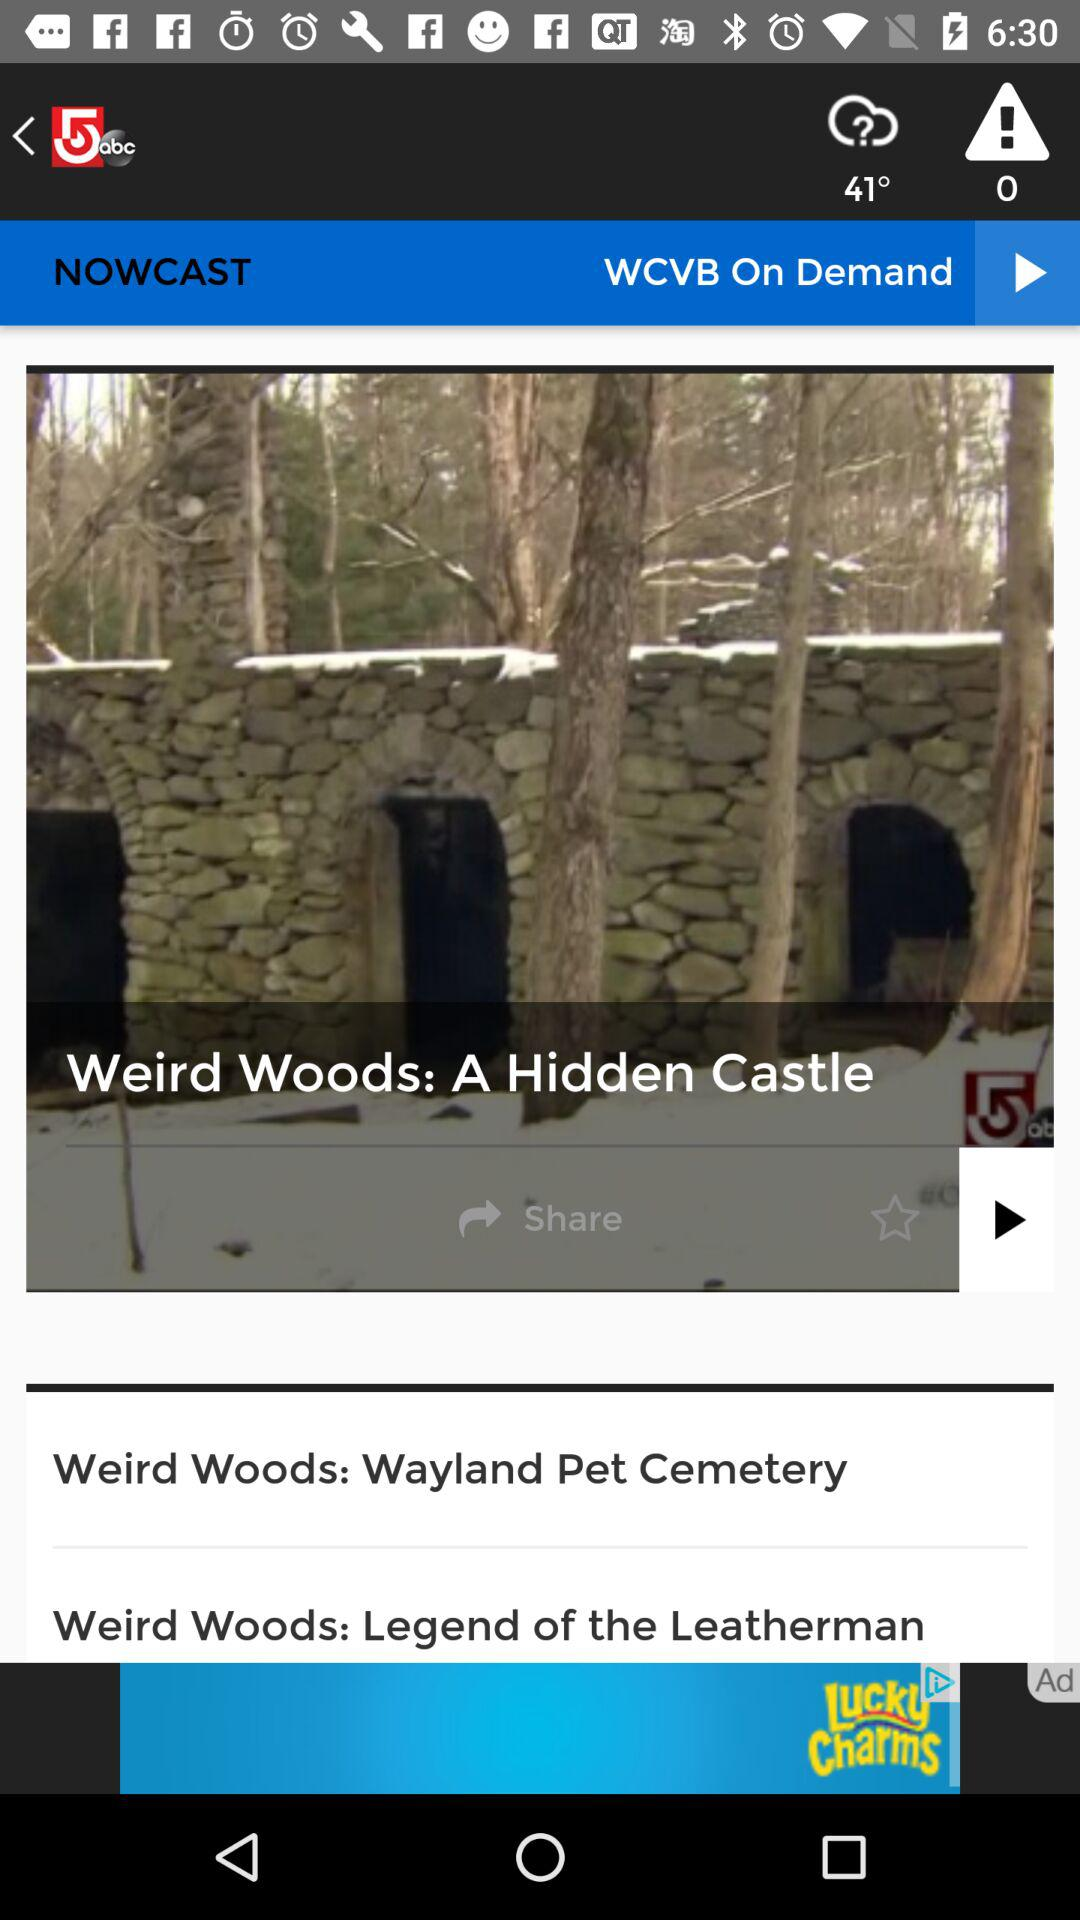What is the temperature? The temperature is 41°. 